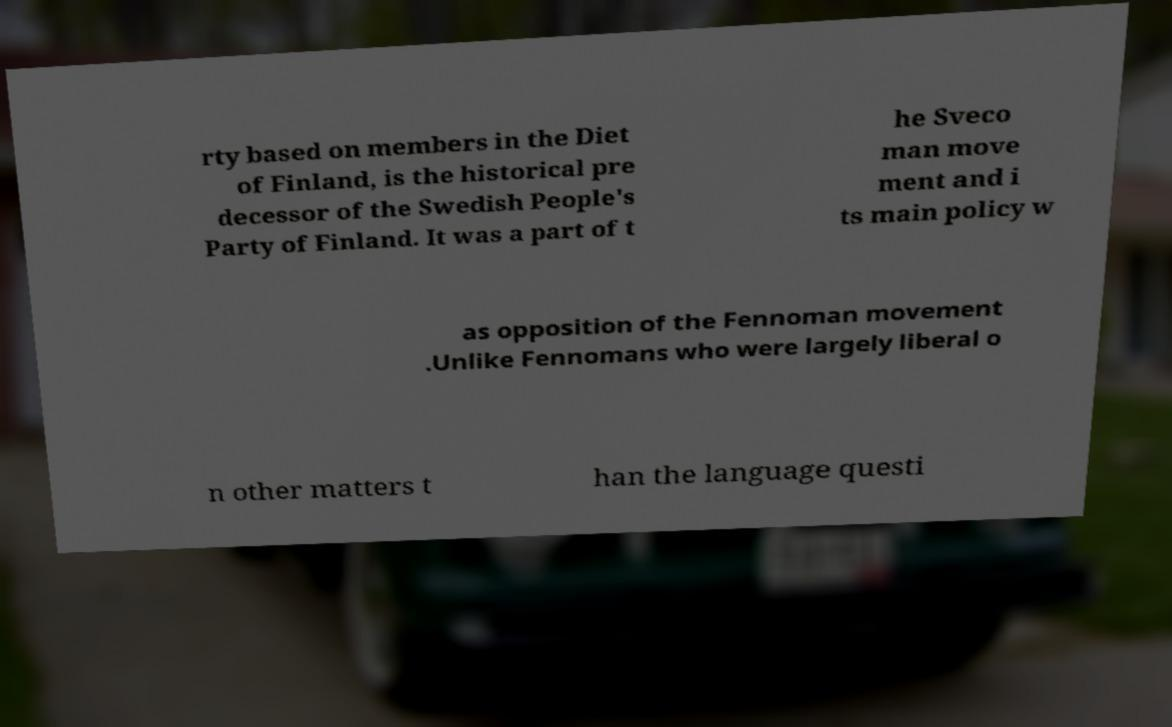There's text embedded in this image that I need extracted. Can you transcribe it verbatim? rty based on members in the Diet of Finland, is the historical pre decessor of the Swedish People's Party of Finland. It was a part of t he Sveco man move ment and i ts main policy w as opposition of the Fennoman movement .Unlike Fennomans who were largely liberal o n other matters t han the language questi 